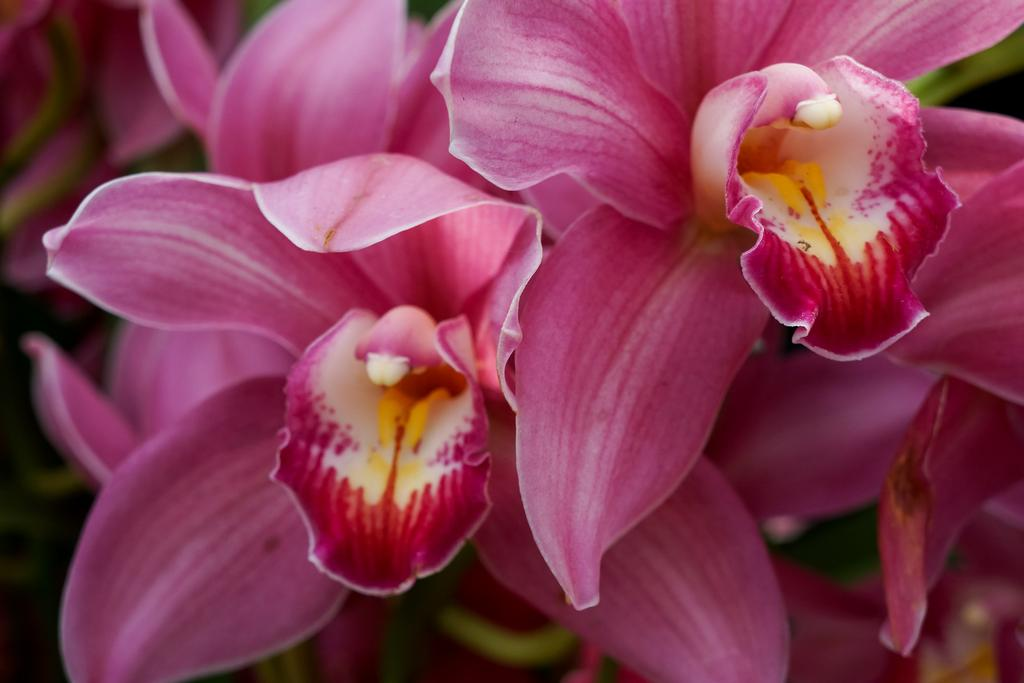What type of flowers can be seen in the image? There are pink color flowers in the image. What else is present in the image besides the flowers? There are plants in the image. Where might this image have been taken? The image may have been taken in a garden. What type of meat is being grilled in the image? There is no meat or grill present in the image; it features pink color flowers and plants. What is the plot of the story being told in the image? The image does not depict a story or plot; it is a still photograph of flowers and plants. 